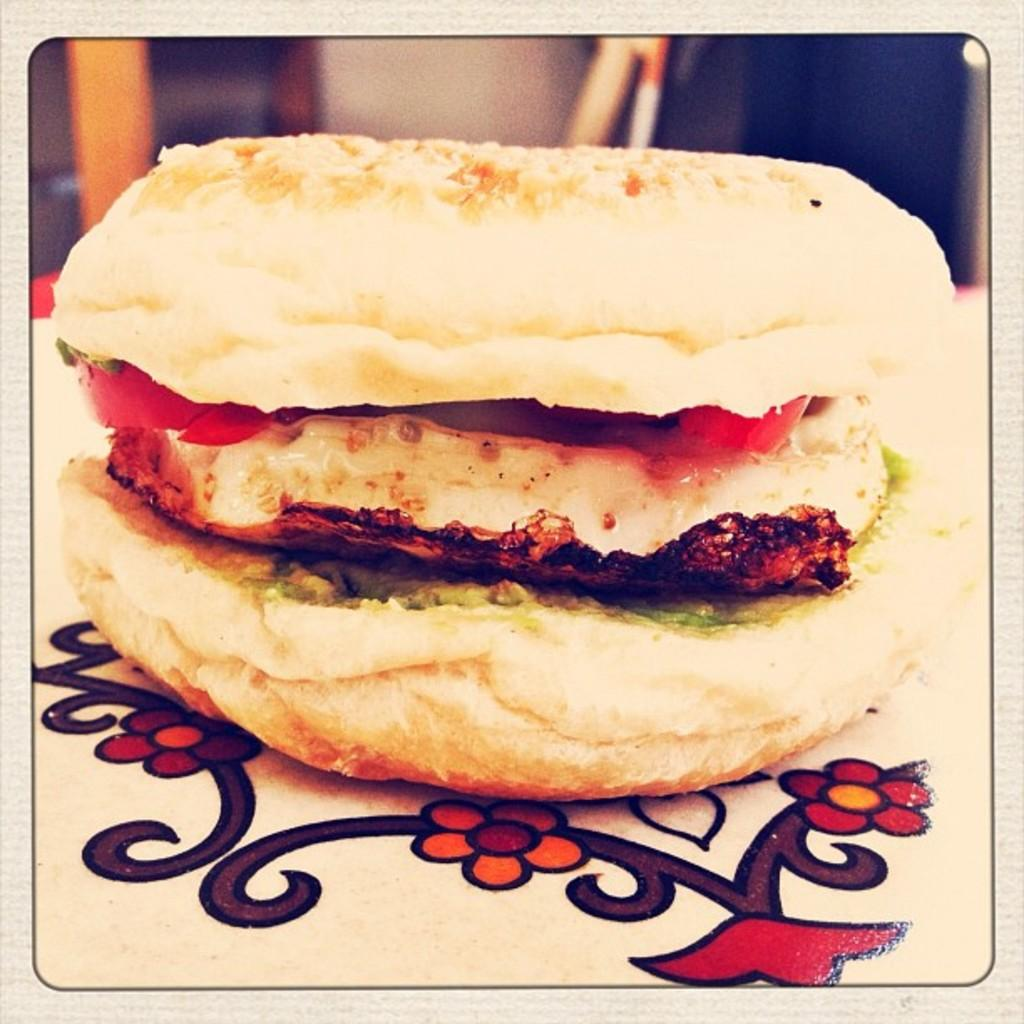What type of food is on the table in the image? There is a burger on the table in the image. What can be seen in the background of the image? There is a window in the background of the image. How is the window positioned in relation to the wall? The window is near a wall in the image. What type of paint is being used to decorate the trains in the image? There are no trains present in the image, so it is not possible to determine what type of paint is being used to decorate them. 